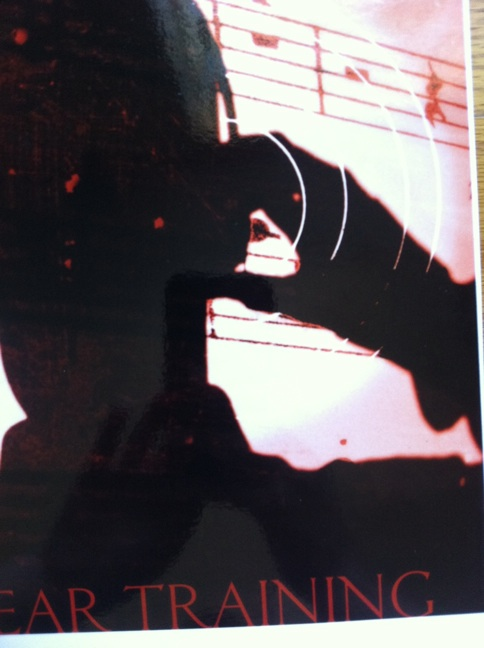What is this? This is an artistic depiction showing a musical theme. It features a shadowed figure, likely of someone playing a musical instrument, with sheet music in the background. The words 'Ear Training' suggest that it may be related to music education or practice. 